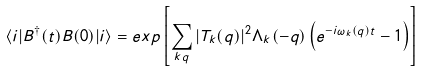Convert formula to latex. <formula><loc_0><loc_0><loc_500><loc_500>\langle i | B ^ { \dagger } ( t ) B ( 0 ) | i \rangle = e x p \left [ \sum _ { { k } { q } } | T _ { k } ( { q } ) | ^ { 2 } \Lambda _ { k } ( - { q } ) \left ( e ^ { - i \omega _ { k } ( { q } ) t } - 1 \right ) \right ]</formula> 